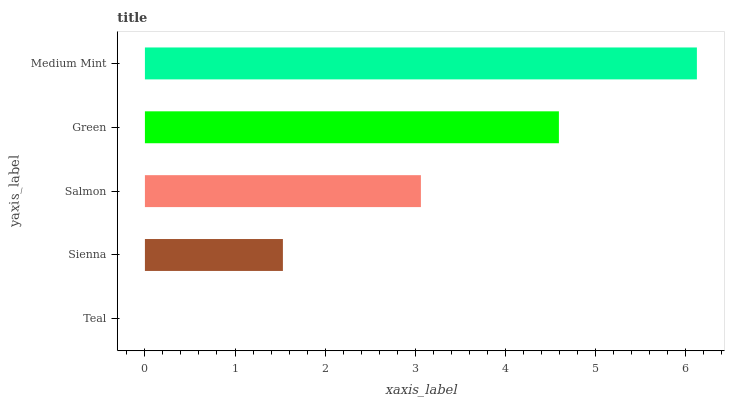Is Teal the minimum?
Answer yes or no. Yes. Is Medium Mint the maximum?
Answer yes or no. Yes. Is Sienna the minimum?
Answer yes or no. No. Is Sienna the maximum?
Answer yes or no. No. Is Sienna greater than Teal?
Answer yes or no. Yes. Is Teal less than Sienna?
Answer yes or no. Yes. Is Teal greater than Sienna?
Answer yes or no. No. Is Sienna less than Teal?
Answer yes or no. No. Is Salmon the high median?
Answer yes or no. Yes. Is Salmon the low median?
Answer yes or no. Yes. Is Green the high median?
Answer yes or no. No. Is Sienna the low median?
Answer yes or no. No. 